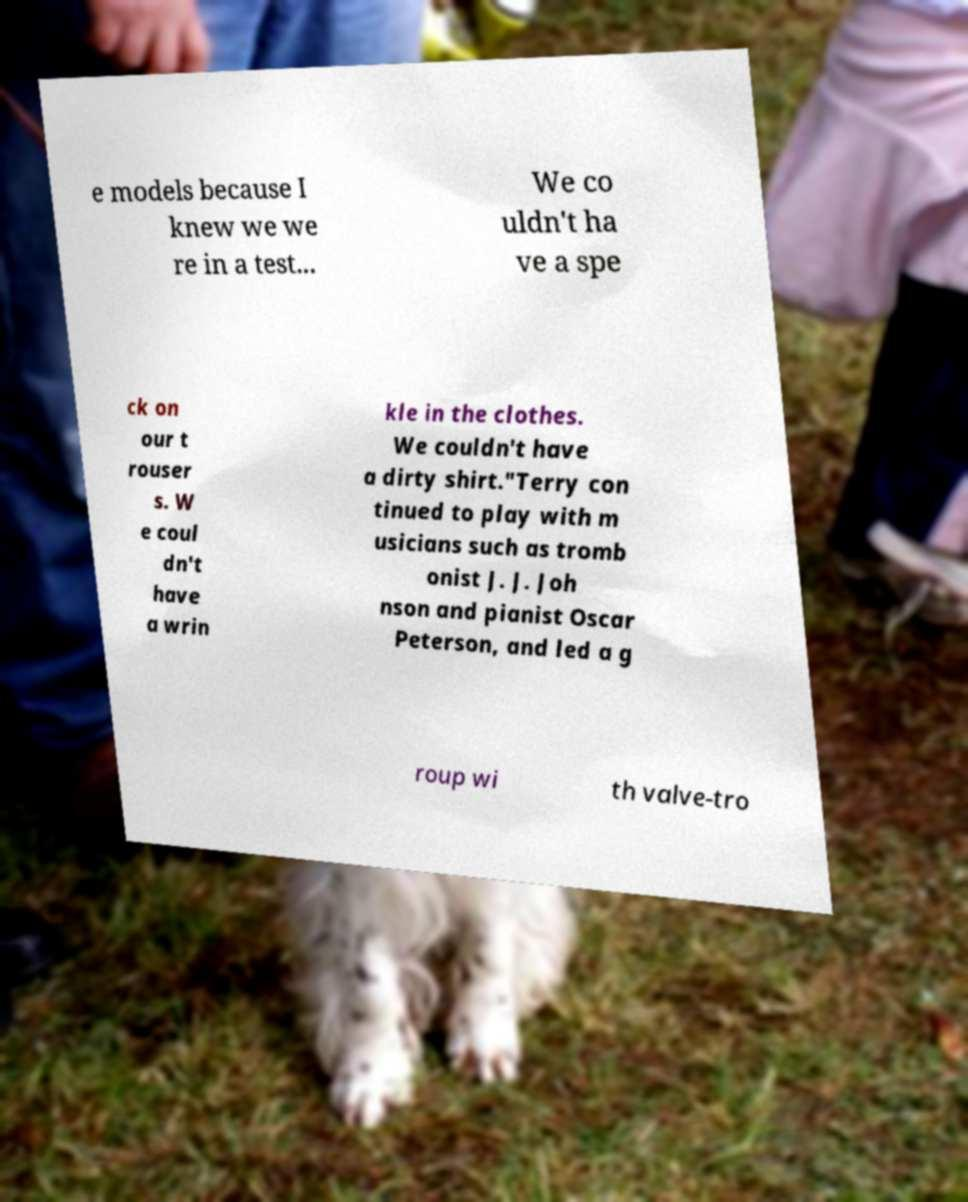Can you read and provide the text displayed in the image?This photo seems to have some interesting text. Can you extract and type it out for me? e models because I knew we we re in a test... We co uldn't ha ve a spe ck on our t rouser s. W e coul dn't have a wrin kle in the clothes. We couldn't have a dirty shirt."Terry con tinued to play with m usicians such as tromb onist J. J. Joh nson and pianist Oscar Peterson, and led a g roup wi th valve-tro 